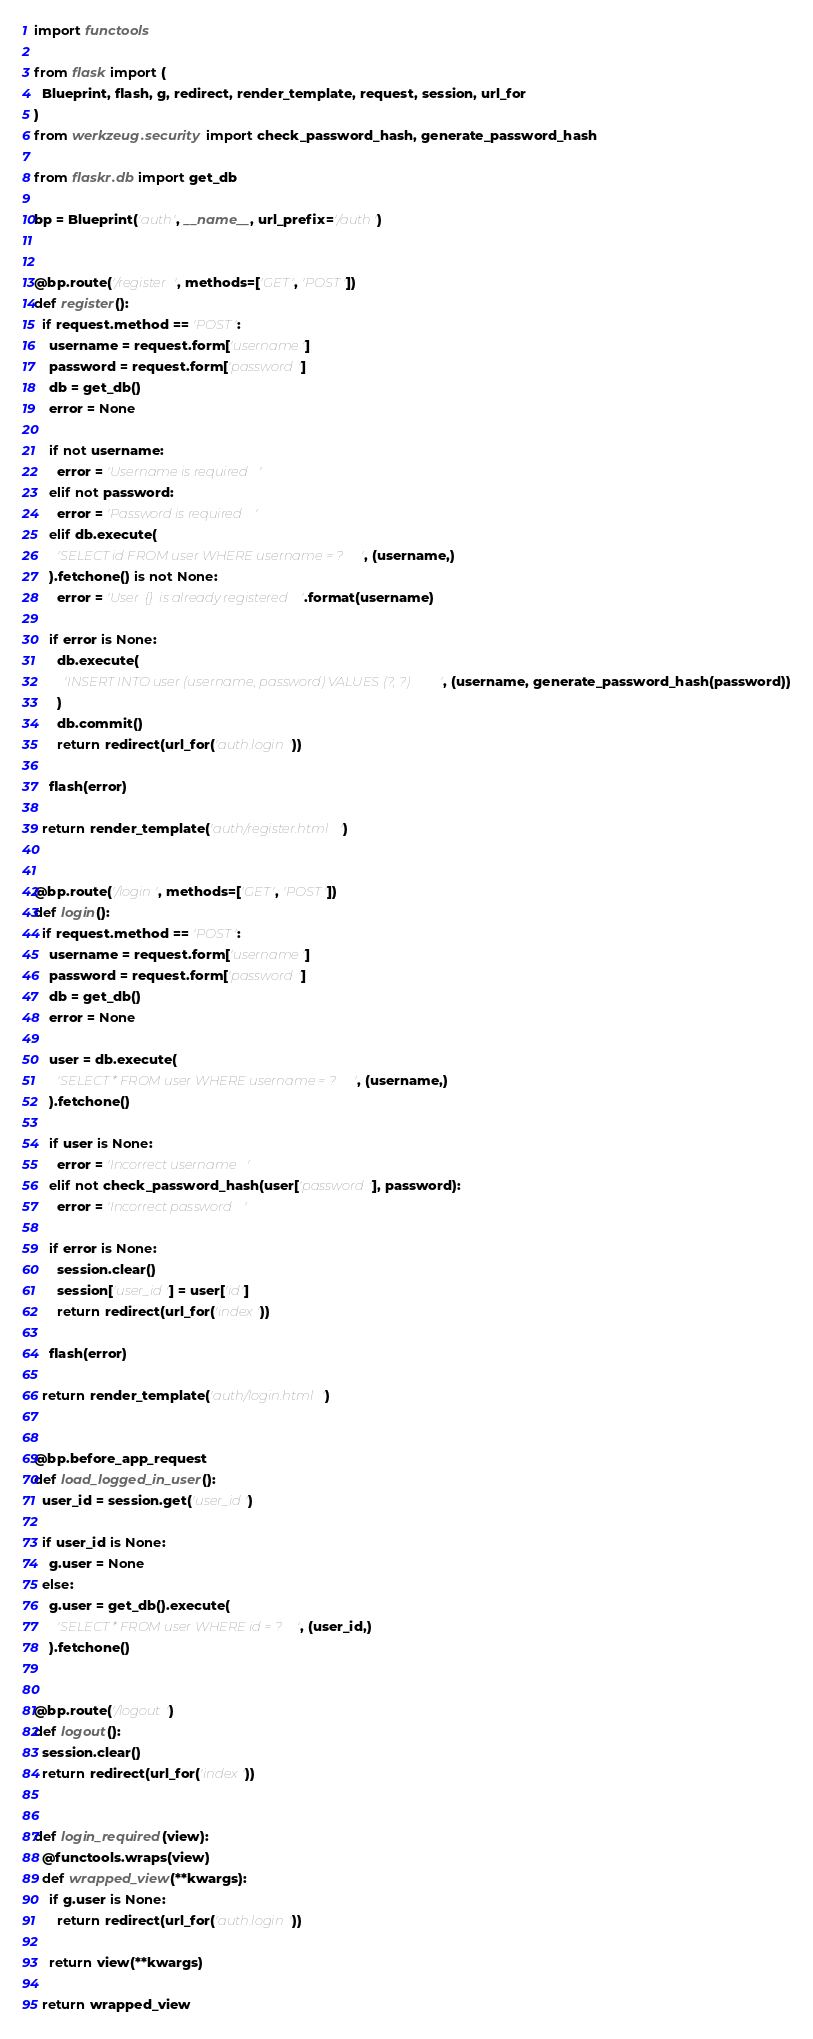Convert code to text. <code><loc_0><loc_0><loc_500><loc_500><_Python_>import functools

from flask import (
  Blueprint, flash, g, redirect, render_template, request, session, url_for
)
from werkzeug.security import check_password_hash, generate_password_hash

from flaskr.db import get_db

bp = Blueprint('auth', __name__, url_prefix='/auth')


@bp.route('/register', methods=['GET', 'POST'])
def register():
  if request.method == 'POST':
    username = request.form['username']
    password = request.form['password']
    db = get_db()
    error = None

    if not username:
      error = 'Username is required'
    elif not password:
      error = 'Password is required'
    elif db.execute(
      'SELECT id FROM user WHERE username = ?', (username,)
    ).fetchone() is not None:
      error = 'User {} is already registered'.format(username)

    if error is None:
      db.execute(
        'INSERT INTO user (username, password) VALUES (?, ?)', (username, generate_password_hash(password))
      )
      db.commit()
      return redirect(url_for('auth.login'))

    flash(error)

  return render_template('auth/register.html')


@bp.route('/login', methods=['GET', 'POST'])
def login():
  if request.method == 'POST':
    username = request.form['username']
    password = request.form['password']
    db = get_db()
    error = None

    user = db.execute(
      'SELECT * FROM user WHERE username = ?', (username,)
    ).fetchone()

    if user is None:
      error = 'Incorrect username'
    elif not check_password_hash(user['password'], password):
      error = 'Incorrect password'

    if error is None:
      session.clear()
      session['user_id'] = user['id']
      return redirect(url_for('index'))

    flash(error)

  return render_template('auth/login.html')


@bp.before_app_request
def load_logged_in_user():
  user_id = session.get('user_id')

  if user_id is None:
    g.user = None
  else:
    g.user = get_db().execute(
      'SELECT * FROM user WHERE id = ?', (user_id,)
    ).fetchone()


@bp.route('/logout')
def logout():
  session.clear()
  return redirect(url_for('index'))


def login_required(view):
  @functools.wraps(view)
  def wrapped_view(**kwargs):
    if g.user is None:
      return redirect(url_for('auth.login'))

    return view(**kwargs)

  return wrapped_view</code> 